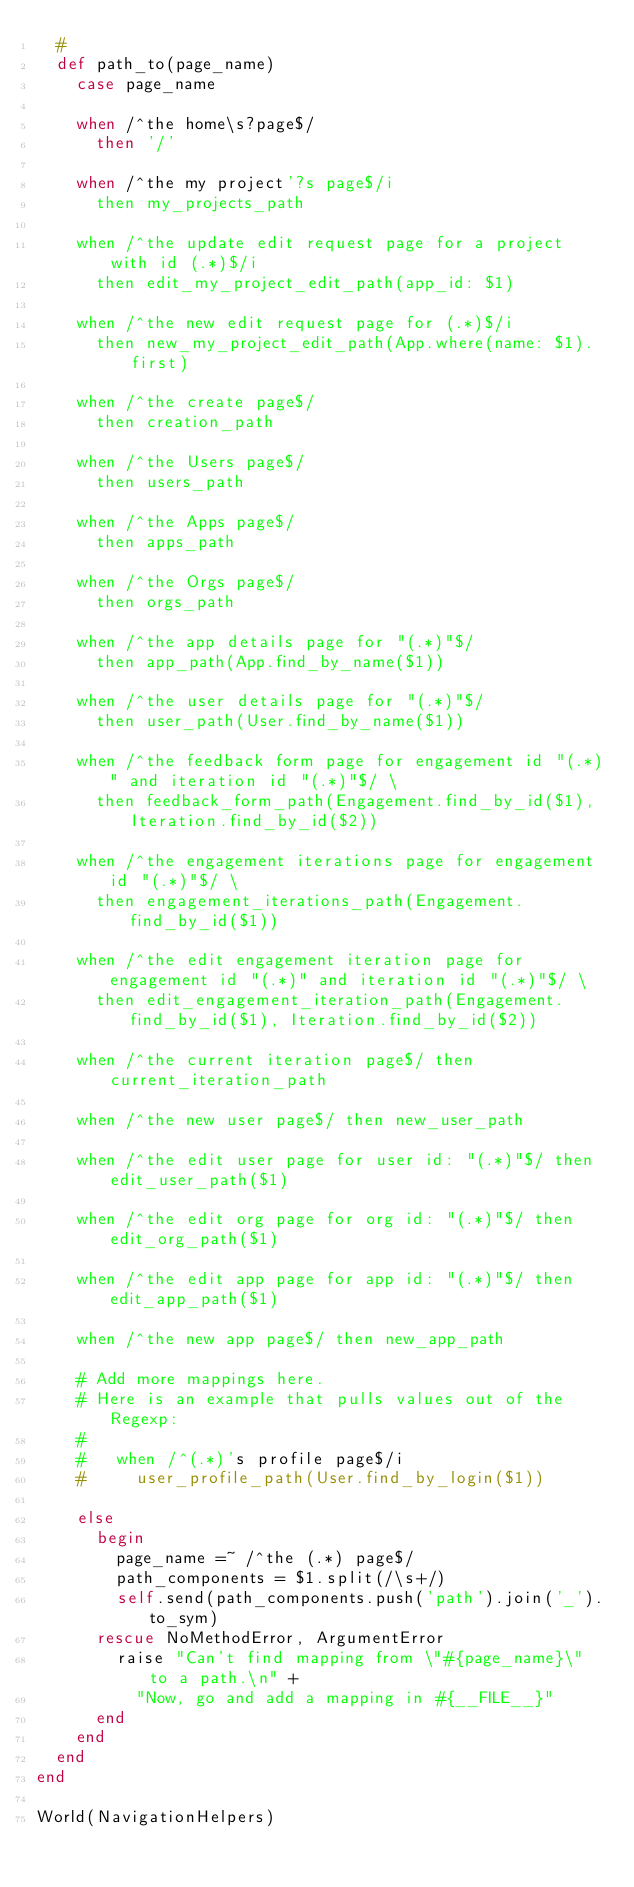Convert code to text. <code><loc_0><loc_0><loc_500><loc_500><_Ruby_>  #
  def path_to(page_name)
    case page_name

    when /^the home\s?page$/
      then '/'

    when /^the my project'?s page$/i
      then my_projects_path

    when /^the update edit request page for a project with id (.*)$/i
      then edit_my_project_edit_path(app_id: $1)

    when /^the new edit request page for (.*)$/i
      then new_my_project_edit_path(App.where(name: $1).first)

    when /^the create page$/
      then creation_path

    when /^the Users page$/
      then users_path

    when /^the Apps page$/
      then apps_path

    when /^the Orgs page$/
      then orgs_path

    when /^the app details page for "(.*)"$/
      then app_path(App.find_by_name($1))

    when /^the user details page for "(.*)"$/
      then user_path(User.find_by_name($1))

    when /^the feedback form page for engagement id "(.*)" and iteration id "(.*)"$/ \
      then feedback_form_path(Engagement.find_by_id($1), Iteration.find_by_id($2))

    when /^the engagement iterations page for engagement id "(.*)"$/ \
      then engagement_iterations_path(Engagement.find_by_id($1))

    when /^the edit engagement iteration page for engagement id "(.*)" and iteration id "(.*)"$/ \
      then edit_engagement_iteration_path(Engagement.find_by_id($1), Iteration.find_by_id($2))

    when /^the current iteration page$/ then current_iteration_path

    when /^the new user page$/ then new_user_path

    when /^the edit user page for user id: "(.*)"$/ then edit_user_path($1)

    when /^the edit org page for org id: "(.*)"$/ then edit_org_path($1)

    when /^the edit app page for app id: "(.*)"$/ then edit_app_path($1)

    when /^the new app page$/ then new_app_path

    # Add more mappings here.
    # Here is an example that pulls values out of the Regexp:
    #
    #   when /^(.*)'s profile page$/i
    #     user_profile_path(User.find_by_login($1))

    else
      begin
        page_name =~ /^the (.*) page$/
        path_components = $1.split(/\s+/)
        self.send(path_components.push('path').join('_').to_sym)
      rescue NoMethodError, ArgumentError
        raise "Can't find mapping from \"#{page_name}\" to a path.\n" +
          "Now, go and add a mapping in #{__FILE__}"
      end
    end
  end
end

World(NavigationHelpers)
</code> 